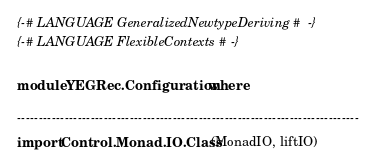Convert code to text. <code><loc_0><loc_0><loc_500><loc_500><_Haskell_>{-# LANGUAGE GeneralizedNewtypeDeriving #-}
{-# LANGUAGE FlexibleContexts #-}

module YEGRec.Configuration where

-------------------------------------------------------------------------------
import Control.Monad.IO.Class (MonadIO, liftIO)</code> 